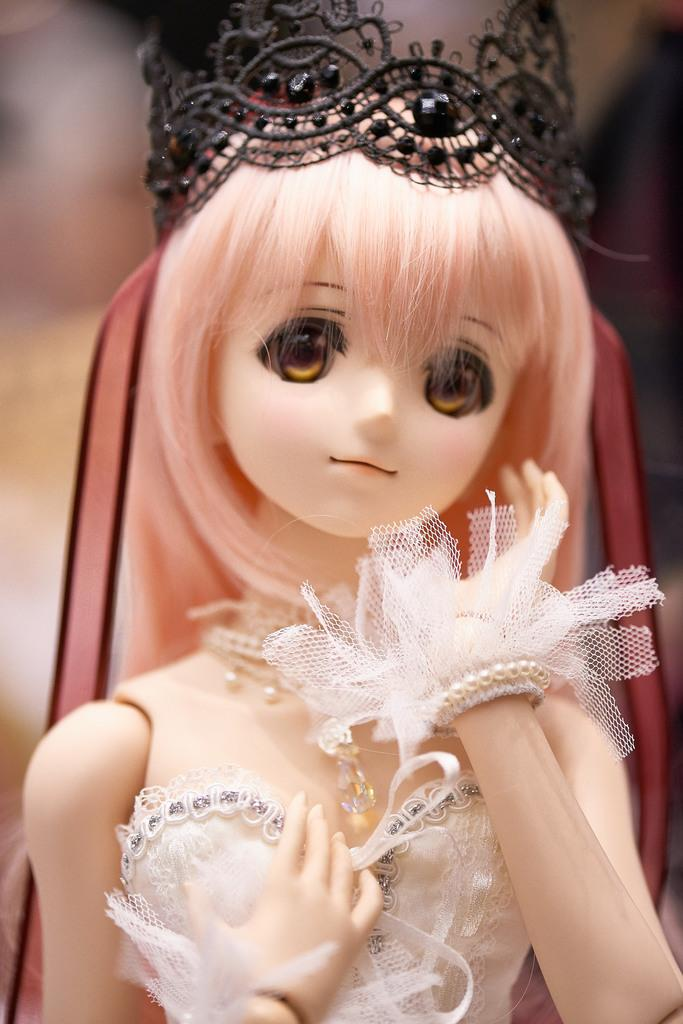What type of toy is in the image? There is a Barbie doll in the image. What is the Barbie doll wearing? The Barbie doll is wearing a white dress. What accessory is on the Barbie doll's head? There is a black color crown on the Barbie doll's head. How would you describe the background of the image? The background of the image is blurred. What type of rice is being cooked in the background of the image? There is no rice present in the image; it only features a Barbie doll with a white dress and a black color crown. 